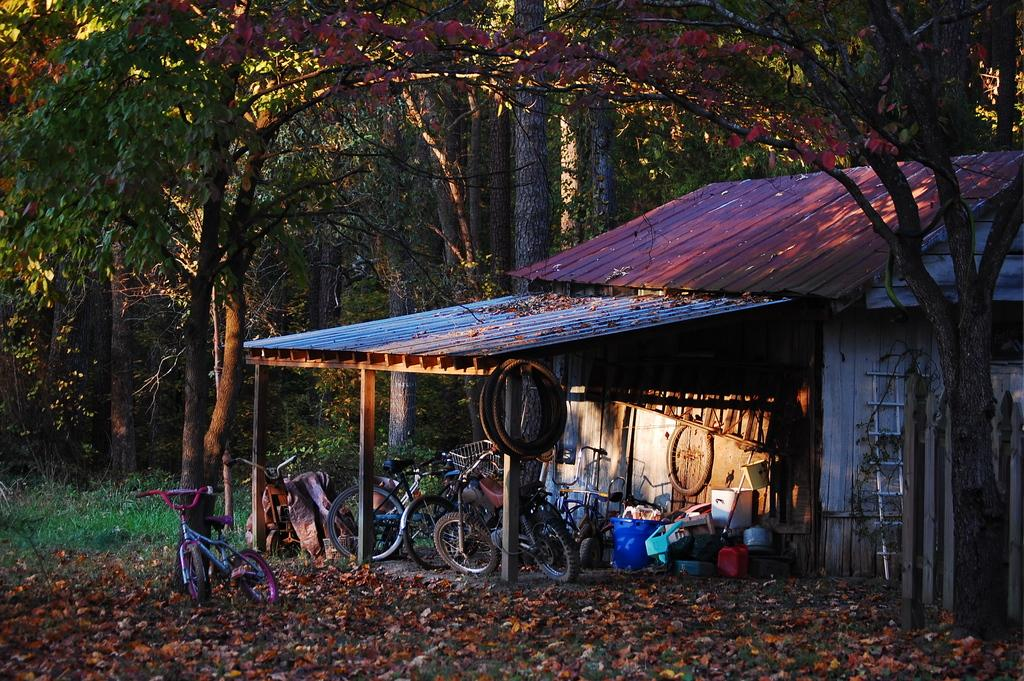What type of structure is visible in the picture? There is a house in the picture. What mode of transportation can be seen in the picture? There are bicycles in the picture. What type of objects are present in the picture? There are tyres and other objects in the picture. What can be seen in the background of the picture? There are plants and trees in the background of the picture. What type of leather is used to make the bun in the picture? There is no bun or leather present in the picture. How does the crush affect the bicycles in the picture? There is no crush or any indication of damage to the bicycles in the picture. 